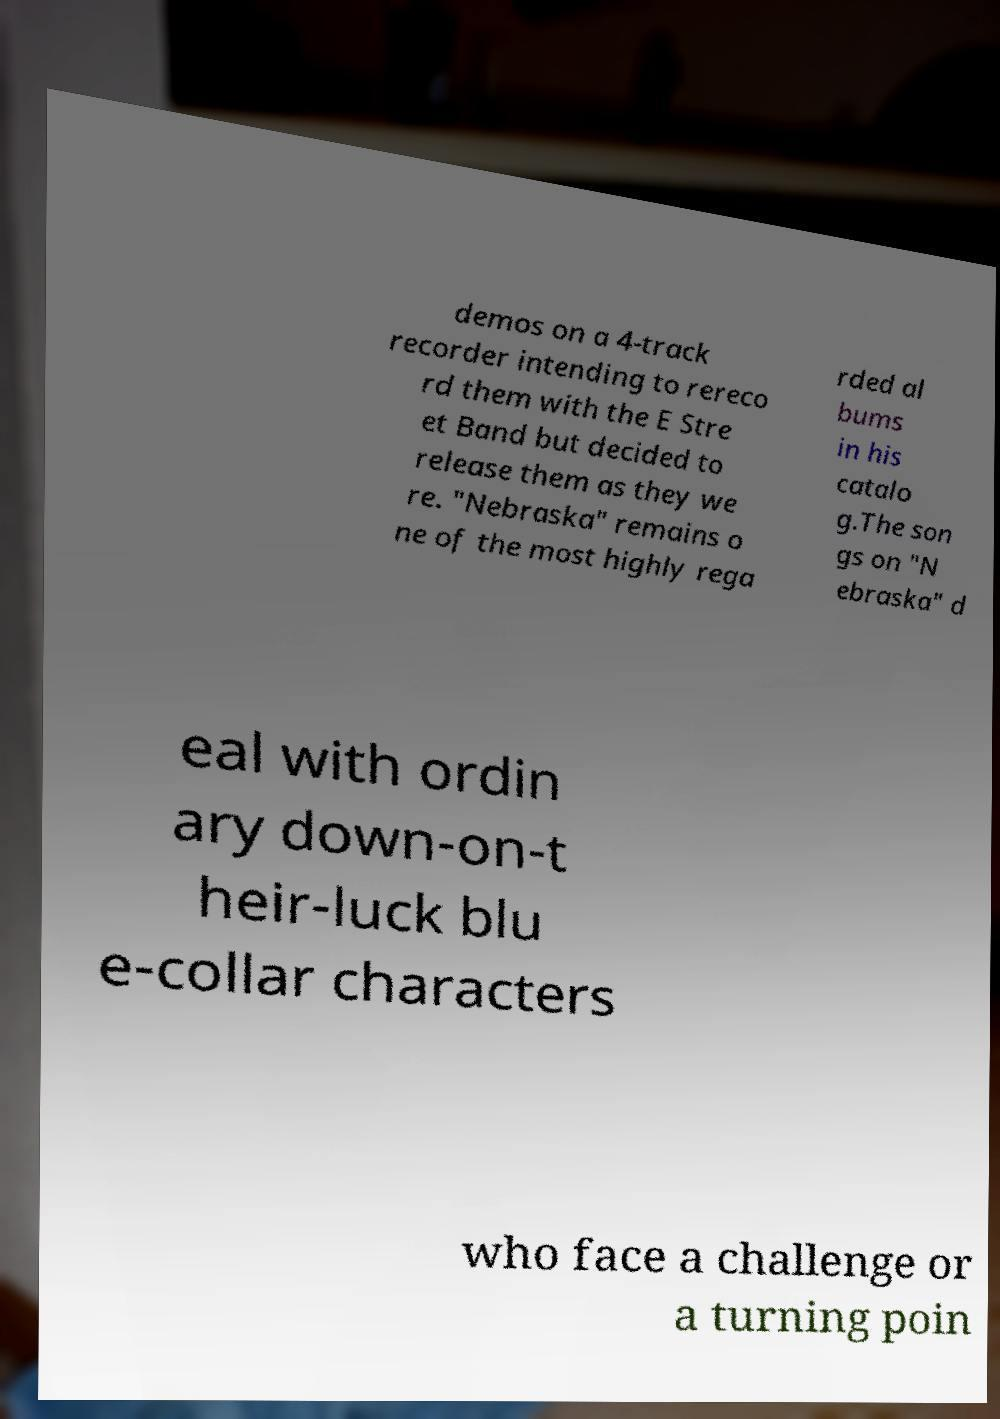For documentation purposes, I need the text within this image transcribed. Could you provide that? demos on a 4-track recorder intending to rereco rd them with the E Stre et Band but decided to release them as they we re. "Nebraska" remains o ne of the most highly rega rded al bums in his catalo g.The son gs on "N ebraska" d eal with ordin ary down-on-t heir-luck blu e-collar characters who face a challenge or a turning poin 